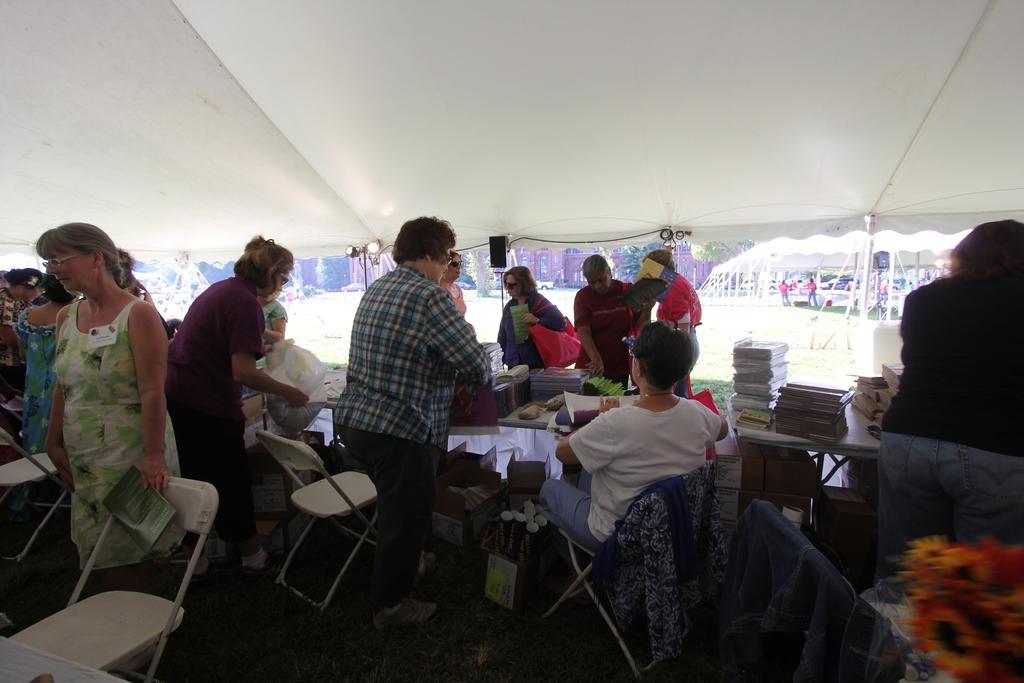Can you describe this image briefly? In the image we can see group of persons were sitting and standing around the table. On table we can see books,papers,cloth etc. Coming to background we can see tent,building,tree,grass. 